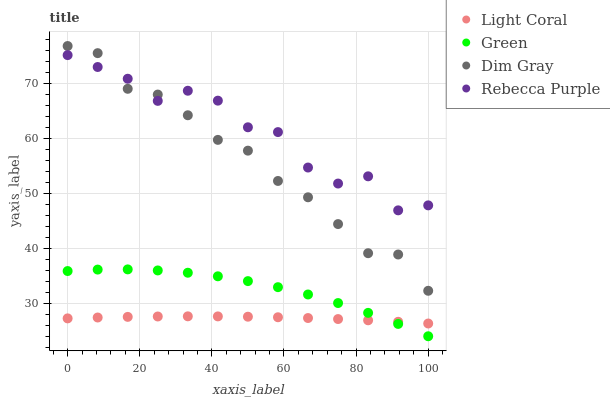Does Light Coral have the minimum area under the curve?
Answer yes or no. Yes. Does Rebecca Purple have the maximum area under the curve?
Answer yes or no. Yes. Does Dim Gray have the minimum area under the curve?
Answer yes or no. No. Does Dim Gray have the maximum area under the curve?
Answer yes or no. No. Is Light Coral the smoothest?
Answer yes or no. Yes. Is Rebecca Purple the roughest?
Answer yes or no. Yes. Is Dim Gray the smoothest?
Answer yes or no. No. Is Dim Gray the roughest?
Answer yes or no. No. Does Green have the lowest value?
Answer yes or no. Yes. Does Dim Gray have the lowest value?
Answer yes or no. No. Does Dim Gray have the highest value?
Answer yes or no. Yes. Does Green have the highest value?
Answer yes or no. No. Is Green less than Rebecca Purple?
Answer yes or no. Yes. Is Rebecca Purple greater than Light Coral?
Answer yes or no. Yes. Does Green intersect Light Coral?
Answer yes or no. Yes. Is Green less than Light Coral?
Answer yes or no. No. Is Green greater than Light Coral?
Answer yes or no. No. Does Green intersect Rebecca Purple?
Answer yes or no. No. 